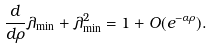Convert formula to latex. <formula><loc_0><loc_0><loc_500><loc_500>\frac { d } { d \rho } \lambda _ { \min } + \lambda _ { \min } ^ { 2 } = 1 + O ( e ^ { - \alpha \rho } ) .</formula> 